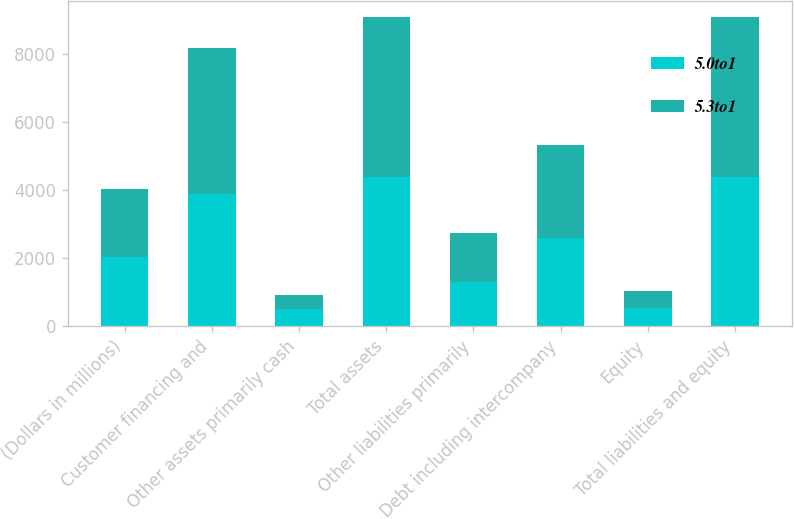Convert chart to OTSL. <chart><loc_0><loc_0><loc_500><loc_500><stacked_bar_chart><ecel><fcel>(Dollars in millions)<fcel>Customer financing and<fcel>Other assets primarily cash<fcel>Total assets<fcel>Other liabilities primarily<fcel>Debt including intercompany<fcel>Equity<fcel>Total liabilities and equity<nl><fcel>5.0to1<fcel>2013<fcel>3883<fcel>505<fcel>4388<fcel>1296<fcel>2577<fcel>515<fcel>4388<nl><fcel>5.3to1<fcel>2012<fcel>4290<fcel>402<fcel>4692<fcel>1429<fcel>2742<fcel>521<fcel>4692<nl></chart> 